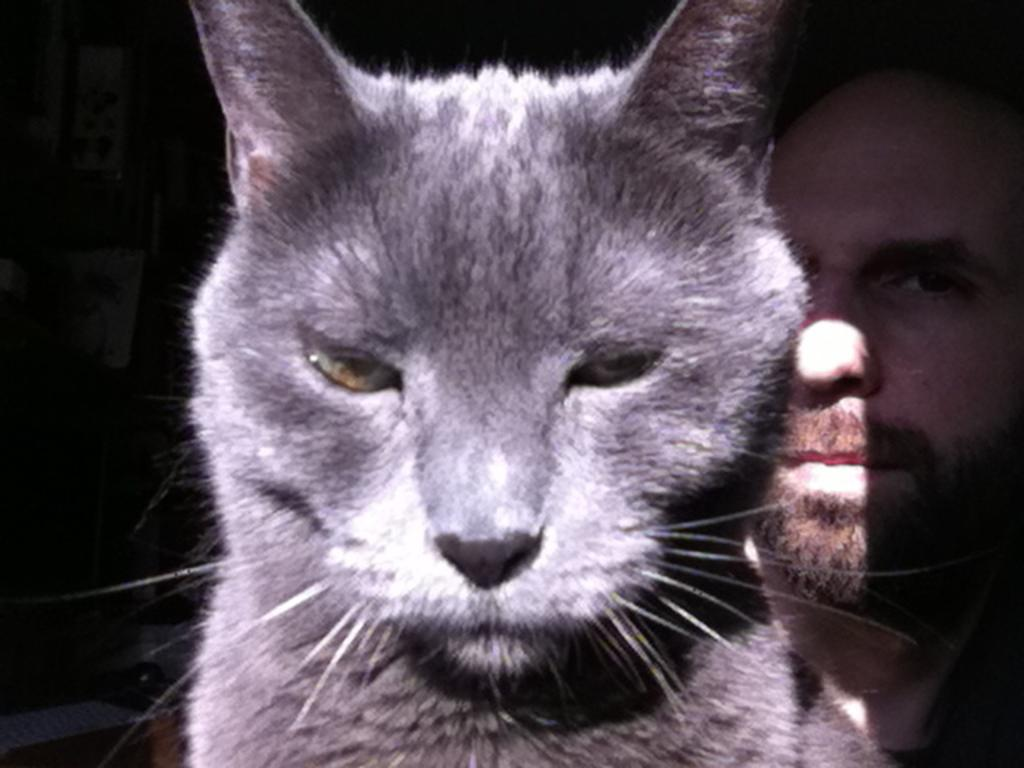Who or what is present in the image? There is a person and a cat in the image. Can you describe the cat in the image? The cat is one of the subjects in the image. What can be seen on the right side of the image in the background? There are objects in the background on the right side of the image. What type of jewel is the cat wearing around its neck in the image? There is no jewel present around the cat's neck in the image. How does the muscle of the person in the image appear to be functioning? There is no mention of the person's muscles or their function in the image. 